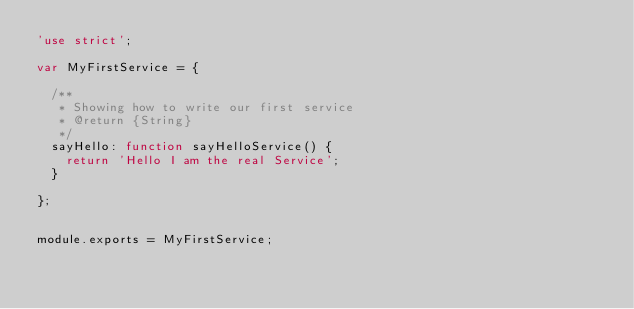Convert code to text. <code><loc_0><loc_0><loc_500><loc_500><_JavaScript_>'use strict';

var MyFirstService = {

  /**
   * Showing how to write our first service
   * @return {String}
   */
  sayHello: function sayHelloService() {
    return 'Hello I am the real Service';
  }

};


module.exports = MyFirstService;
</code> 